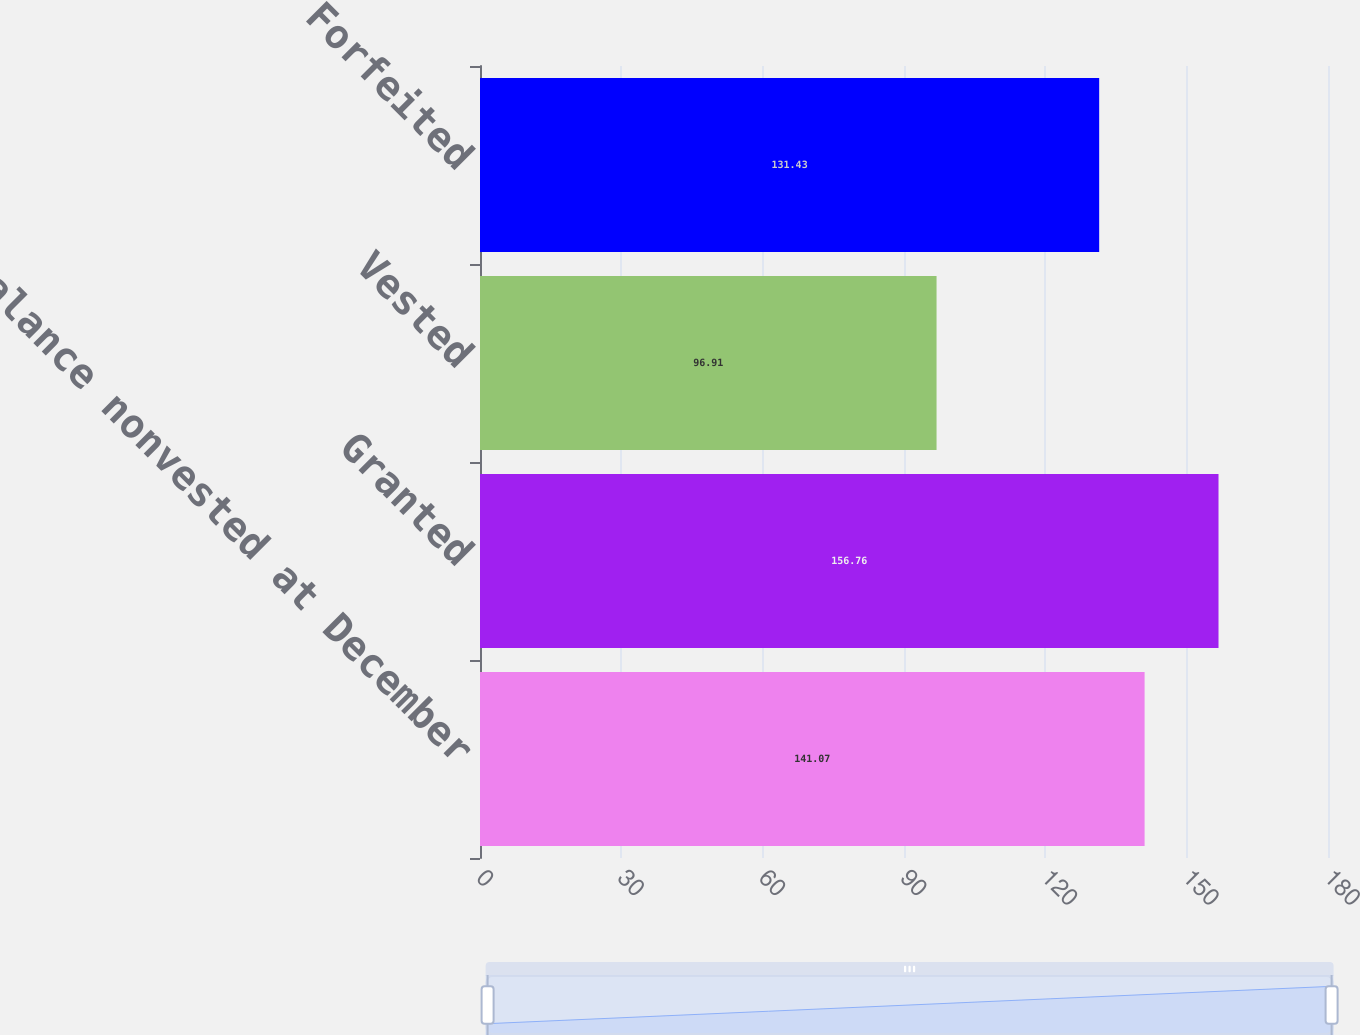Convert chart to OTSL. <chart><loc_0><loc_0><loc_500><loc_500><bar_chart><fcel>Balance nonvested at December<fcel>Granted<fcel>Vested<fcel>Forfeited<nl><fcel>141.07<fcel>156.76<fcel>96.91<fcel>131.43<nl></chart> 